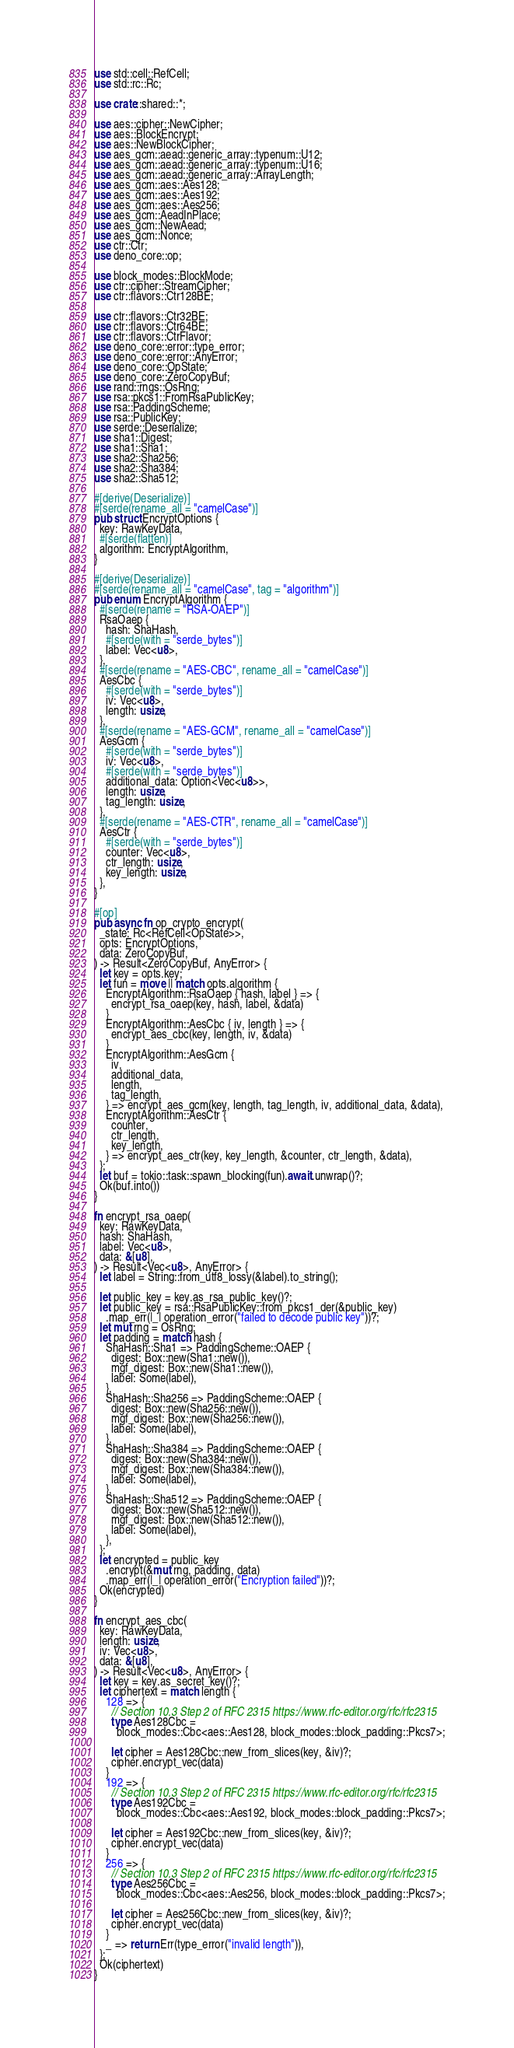Convert code to text. <code><loc_0><loc_0><loc_500><loc_500><_Rust_>use std::cell::RefCell;
use std::rc::Rc;

use crate::shared::*;

use aes::cipher::NewCipher;
use aes::BlockEncrypt;
use aes::NewBlockCipher;
use aes_gcm::aead::generic_array::typenum::U12;
use aes_gcm::aead::generic_array::typenum::U16;
use aes_gcm::aead::generic_array::ArrayLength;
use aes_gcm::aes::Aes128;
use aes_gcm::aes::Aes192;
use aes_gcm::aes::Aes256;
use aes_gcm::AeadInPlace;
use aes_gcm::NewAead;
use aes_gcm::Nonce;
use ctr::Ctr;
use deno_core::op;

use block_modes::BlockMode;
use ctr::cipher::StreamCipher;
use ctr::flavors::Ctr128BE;

use ctr::flavors::Ctr32BE;
use ctr::flavors::Ctr64BE;
use ctr::flavors::CtrFlavor;
use deno_core::error::type_error;
use deno_core::error::AnyError;
use deno_core::OpState;
use deno_core::ZeroCopyBuf;
use rand::rngs::OsRng;
use rsa::pkcs1::FromRsaPublicKey;
use rsa::PaddingScheme;
use rsa::PublicKey;
use serde::Deserialize;
use sha1::Digest;
use sha1::Sha1;
use sha2::Sha256;
use sha2::Sha384;
use sha2::Sha512;

#[derive(Deserialize)]
#[serde(rename_all = "camelCase")]
pub struct EncryptOptions {
  key: RawKeyData,
  #[serde(flatten)]
  algorithm: EncryptAlgorithm,
}

#[derive(Deserialize)]
#[serde(rename_all = "camelCase", tag = "algorithm")]
pub enum EncryptAlgorithm {
  #[serde(rename = "RSA-OAEP")]
  RsaOaep {
    hash: ShaHash,
    #[serde(with = "serde_bytes")]
    label: Vec<u8>,
  },
  #[serde(rename = "AES-CBC", rename_all = "camelCase")]
  AesCbc {
    #[serde(with = "serde_bytes")]
    iv: Vec<u8>,
    length: usize,
  },
  #[serde(rename = "AES-GCM", rename_all = "camelCase")]
  AesGcm {
    #[serde(with = "serde_bytes")]
    iv: Vec<u8>,
    #[serde(with = "serde_bytes")]
    additional_data: Option<Vec<u8>>,
    length: usize,
    tag_length: usize,
  },
  #[serde(rename = "AES-CTR", rename_all = "camelCase")]
  AesCtr {
    #[serde(with = "serde_bytes")]
    counter: Vec<u8>,
    ctr_length: usize,
    key_length: usize,
  },
}

#[op]
pub async fn op_crypto_encrypt(
  _state: Rc<RefCell<OpState>>,
  opts: EncryptOptions,
  data: ZeroCopyBuf,
) -> Result<ZeroCopyBuf, AnyError> {
  let key = opts.key;
  let fun = move || match opts.algorithm {
    EncryptAlgorithm::RsaOaep { hash, label } => {
      encrypt_rsa_oaep(key, hash, label, &data)
    }
    EncryptAlgorithm::AesCbc { iv, length } => {
      encrypt_aes_cbc(key, length, iv, &data)
    }
    EncryptAlgorithm::AesGcm {
      iv,
      additional_data,
      length,
      tag_length,
    } => encrypt_aes_gcm(key, length, tag_length, iv, additional_data, &data),
    EncryptAlgorithm::AesCtr {
      counter,
      ctr_length,
      key_length,
    } => encrypt_aes_ctr(key, key_length, &counter, ctr_length, &data),
  };
  let buf = tokio::task::spawn_blocking(fun).await.unwrap()?;
  Ok(buf.into())
}

fn encrypt_rsa_oaep(
  key: RawKeyData,
  hash: ShaHash,
  label: Vec<u8>,
  data: &[u8],
) -> Result<Vec<u8>, AnyError> {
  let label = String::from_utf8_lossy(&label).to_string();

  let public_key = key.as_rsa_public_key()?;
  let public_key = rsa::RsaPublicKey::from_pkcs1_der(&public_key)
    .map_err(|_| operation_error("failed to decode public key"))?;
  let mut rng = OsRng;
  let padding = match hash {
    ShaHash::Sha1 => PaddingScheme::OAEP {
      digest: Box::new(Sha1::new()),
      mgf_digest: Box::new(Sha1::new()),
      label: Some(label),
    },
    ShaHash::Sha256 => PaddingScheme::OAEP {
      digest: Box::new(Sha256::new()),
      mgf_digest: Box::new(Sha256::new()),
      label: Some(label),
    },
    ShaHash::Sha384 => PaddingScheme::OAEP {
      digest: Box::new(Sha384::new()),
      mgf_digest: Box::new(Sha384::new()),
      label: Some(label),
    },
    ShaHash::Sha512 => PaddingScheme::OAEP {
      digest: Box::new(Sha512::new()),
      mgf_digest: Box::new(Sha512::new()),
      label: Some(label),
    },
  };
  let encrypted = public_key
    .encrypt(&mut rng, padding, data)
    .map_err(|_| operation_error("Encryption failed"))?;
  Ok(encrypted)
}

fn encrypt_aes_cbc(
  key: RawKeyData,
  length: usize,
  iv: Vec<u8>,
  data: &[u8],
) -> Result<Vec<u8>, AnyError> {
  let key = key.as_secret_key()?;
  let ciphertext = match length {
    128 => {
      // Section 10.3 Step 2 of RFC 2315 https://www.rfc-editor.org/rfc/rfc2315
      type Aes128Cbc =
        block_modes::Cbc<aes::Aes128, block_modes::block_padding::Pkcs7>;

      let cipher = Aes128Cbc::new_from_slices(key, &iv)?;
      cipher.encrypt_vec(data)
    }
    192 => {
      // Section 10.3 Step 2 of RFC 2315 https://www.rfc-editor.org/rfc/rfc2315
      type Aes192Cbc =
        block_modes::Cbc<aes::Aes192, block_modes::block_padding::Pkcs7>;

      let cipher = Aes192Cbc::new_from_slices(key, &iv)?;
      cipher.encrypt_vec(data)
    }
    256 => {
      // Section 10.3 Step 2 of RFC 2315 https://www.rfc-editor.org/rfc/rfc2315
      type Aes256Cbc =
        block_modes::Cbc<aes::Aes256, block_modes::block_padding::Pkcs7>;

      let cipher = Aes256Cbc::new_from_slices(key, &iv)?;
      cipher.encrypt_vec(data)
    }
    _ => return Err(type_error("invalid length")),
  };
  Ok(ciphertext)
}
</code> 